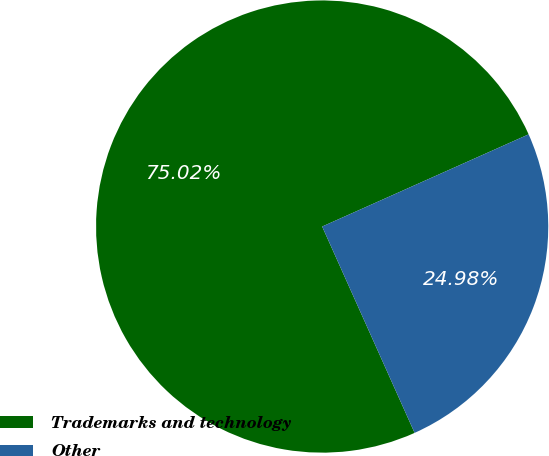Convert chart to OTSL. <chart><loc_0><loc_0><loc_500><loc_500><pie_chart><fcel>Trademarks and technology<fcel>Other<nl><fcel>75.02%<fcel>24.98%<nl></chart> 